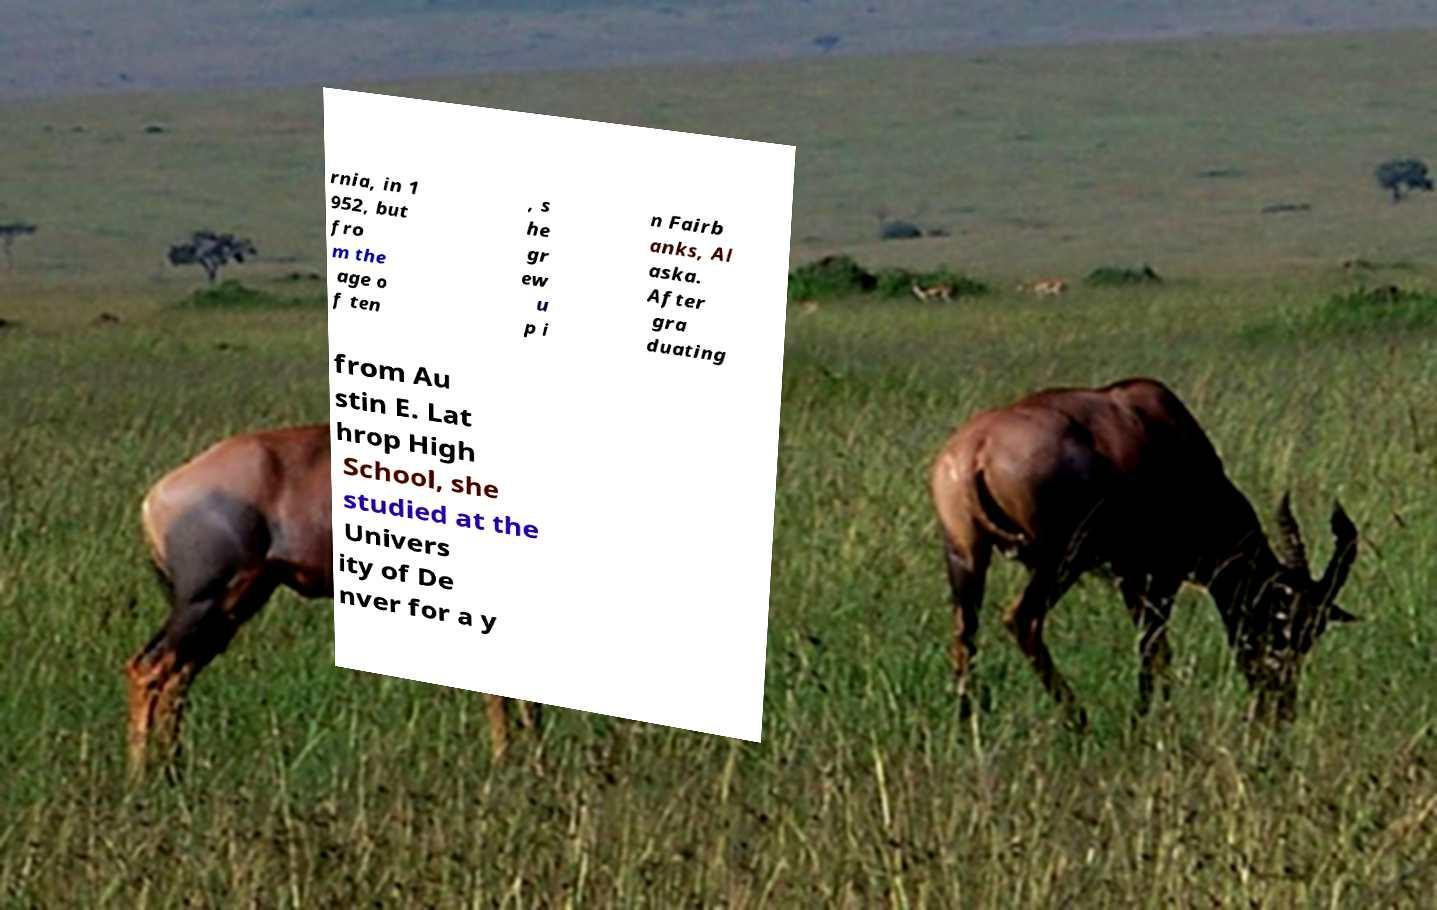There's text embedded in this image that I need extracted. Can you transcribe it verbatim? rnia, in 1 952, but fro m the age o f ten , s he gr ew u p i n Fairb anks, Al aska. After gra duating from Au stin E. Lat hrop High School, she studied at the Univers ity of De nver for a y 